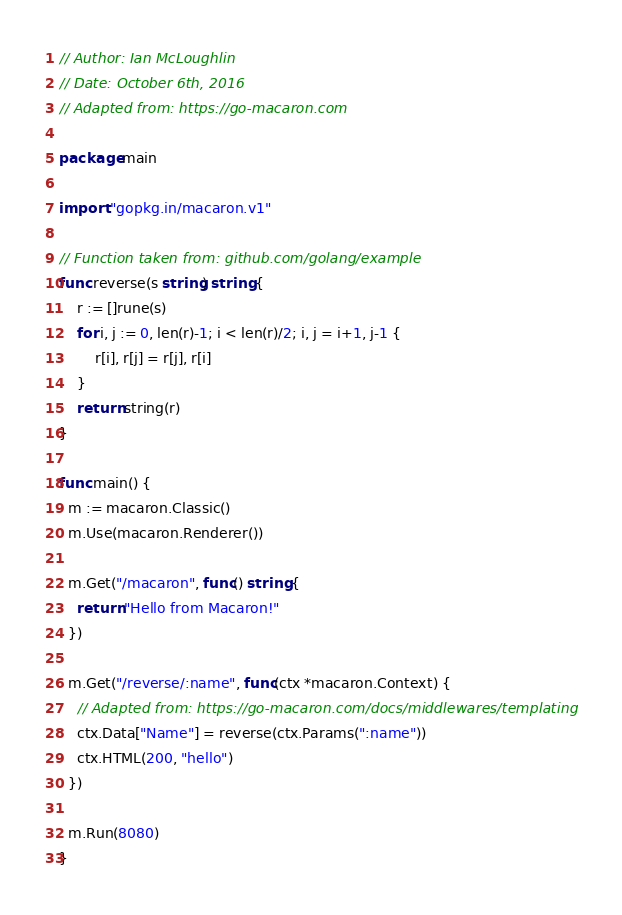<code> <loc_0><loc_0><loc_500><loc_500><_Go_>// Author: Ian McLoughlin
// Date: October 6th, 2016
// Adapted from: https://go-macaron.com

package main

import "gopkg.in/macaron.v1"

// Function taken from: github.com/golang/example
func reverse(s string) string {
	r := []rune(s)
	for i, j := 0, len(r)-1; i < len(r)/2; i, j = i+1, j-1 {
		r[i], r[j] = r[j], r[i]
	}
	return string(r)
}

func main() {
  m := macaron.Classic()
  m.Use(macaron.Renderer())
  
  m.Get("/macaron", func() string {
    return "Hello from Macaron!"
  })
  
  m.Get("/reverse/:name", func(ctx *macaron.Context) {
    // Adapted from: https://go-macaron.com/docs/middlewares/templating
    ctx.Data["Name"] = reverse(ctx.Params(":name"))
    ctx.HTML(200, "hello")
  })
  
  m.Run(8080)
}
</code> 